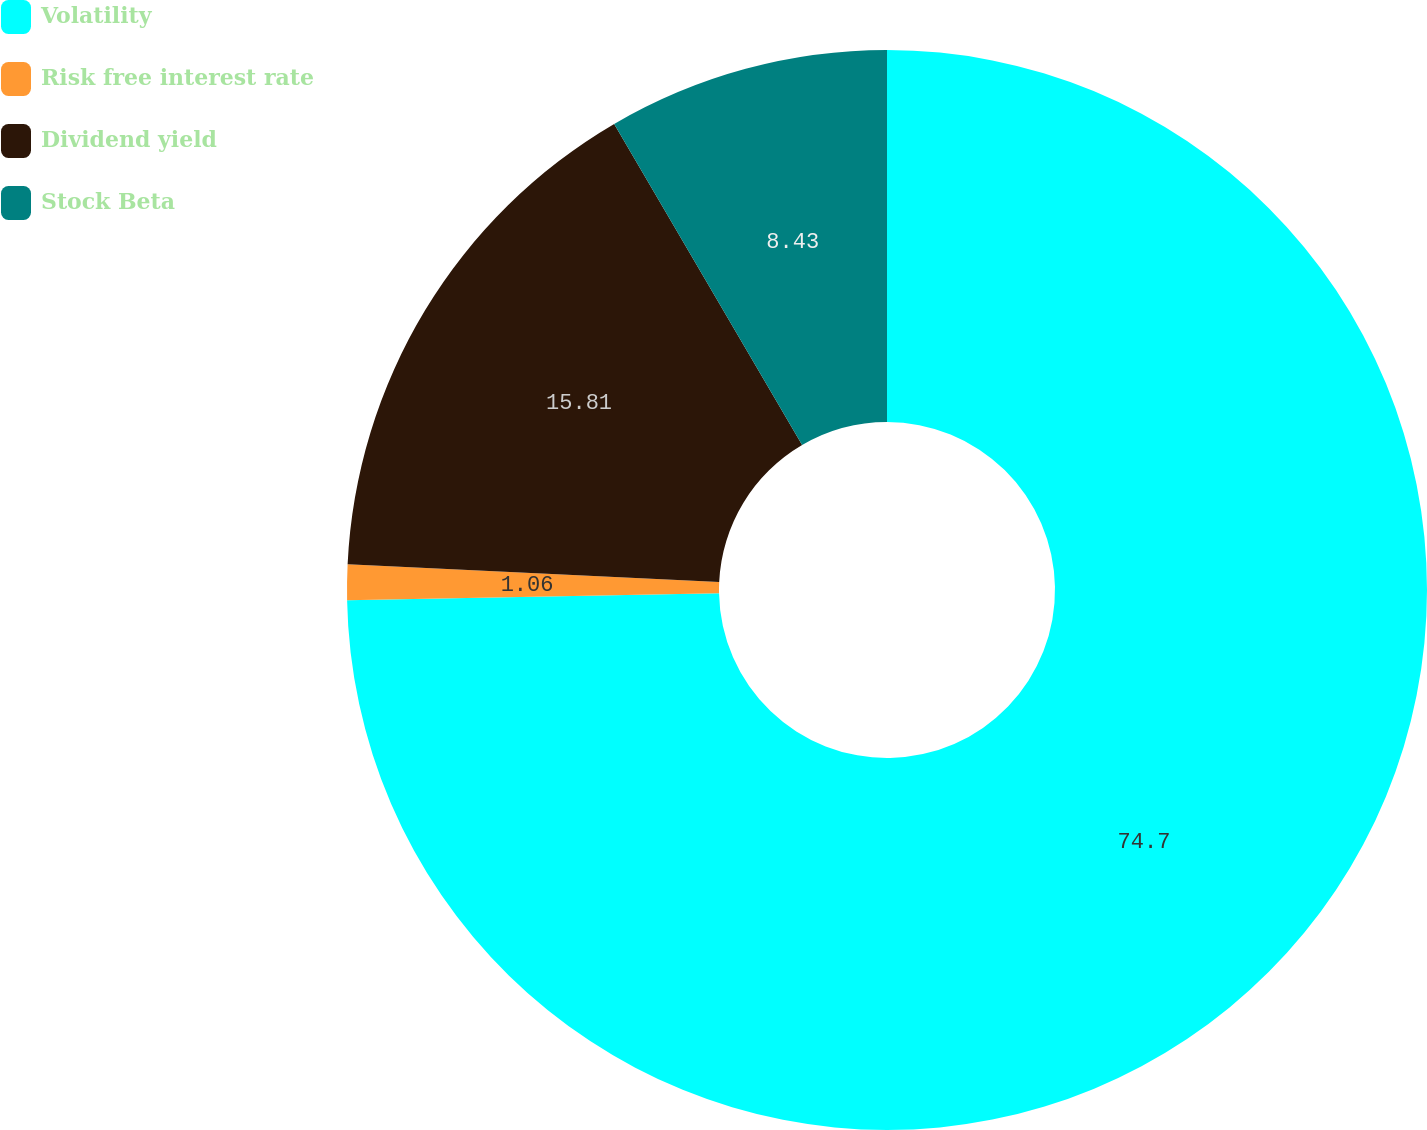Convert chart. <chart><loc_0><loc_0><loc_500><loc_500><pie_chart><fcel>Volatility<fcel>Risk free interest rate<fcel>Dividend yield<fcel>Stock Beta<nl><fcel>74.7%<fcel>1.06%<fcel>15.81%<fcel>8.43%<nl></chart> 